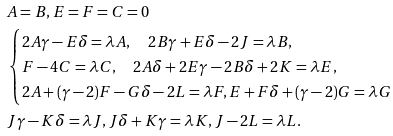<formula> <loc_0><loc_0><loc_500><loc_500>& A = B , E = F = C = 0 \\ & \begin{cases} 2 A \gamma - E \delta = \lambda A , \quad 2 B \gamma + E \delta - 2 J = \lambda B , \\ F - 4 C = \lambda C , \quad 2 A \delta + 2 E \gamma - 2 B \delta + 2 K = \lambda E , \\ 2 A + ( \gamma - 2 ) F - G \delta - 2 L = \lambda F , E + F \delta + ( \gamma - 2 ) G = \lambda G \end{cases} \\ & J \gamma - K \delta = \lambda J , J \delta + K \gamma = \lambda K , J - 2 L = \lambda L .</formula> 